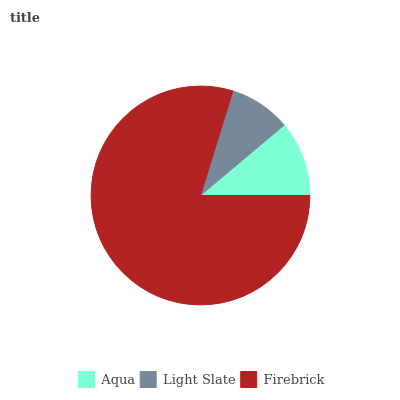Is Light Slate the minimum?
Answer yes or no. Yes. Is Firebrick the maximum?
Answer yes or no. Yes. Is Firebrick the minimum?
Answer yes or no. No. Is Light Slate the maximum?
Answer yes or no. No. Is Firebrick greater than Light Slate?
Answer yes or no. Yes. Is Light Slate less than Firebrick?
Answer yes or no. Yes. Is Light Slate greater than Firebrick?
Answer yes or no. No. Is Firebrick less than Light Slate?
Answer yes or no. No. Is Aqua the high median?
Answer yes or no. Yes. Is Aqua the low median?
Answer yes or no. Yes. Is Light Slate the high median?
Answer yes or no. No. Is Light Slate the low median?
Answer yes or no. No. 